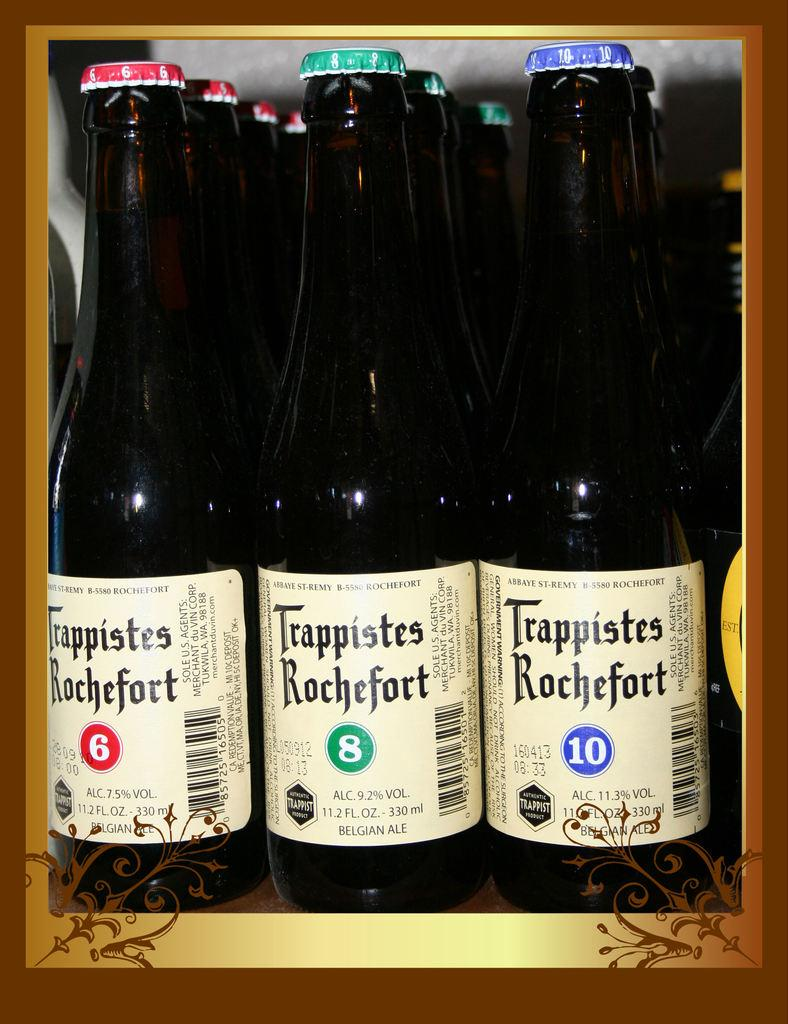<image>
Present a compact description of the photo's key features. the word trappistes that is on a wine bottle 